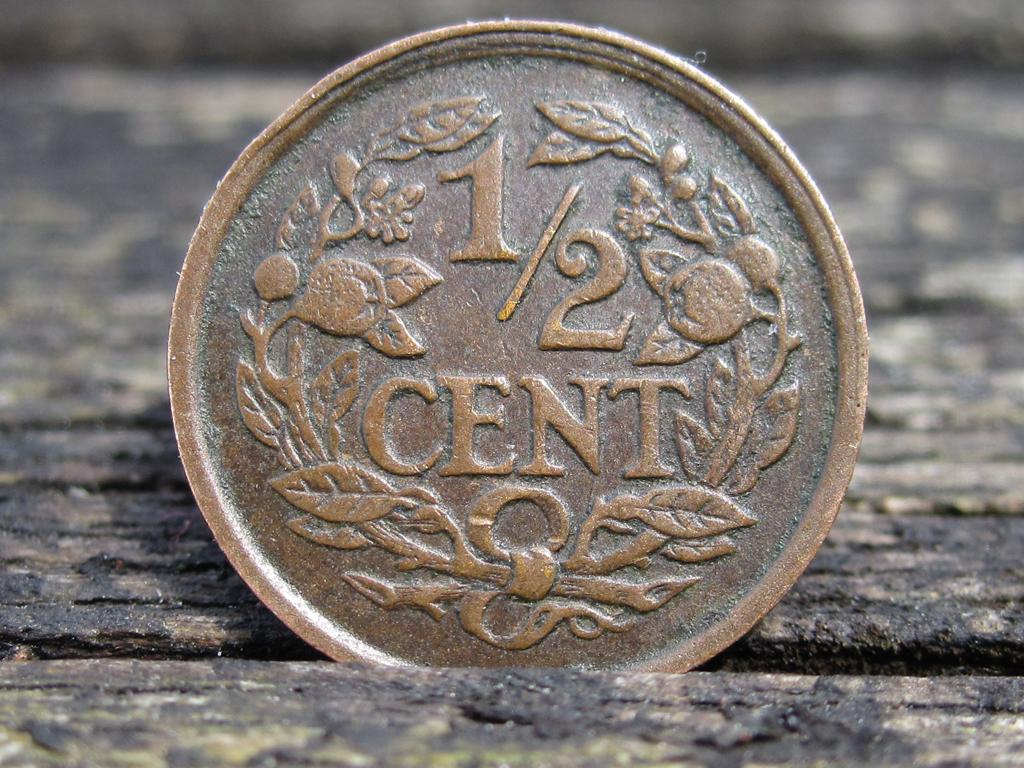<image>
Offer a succinct explanation of the picture presented. 1/2 cent copper coin with plants and vines on it. 